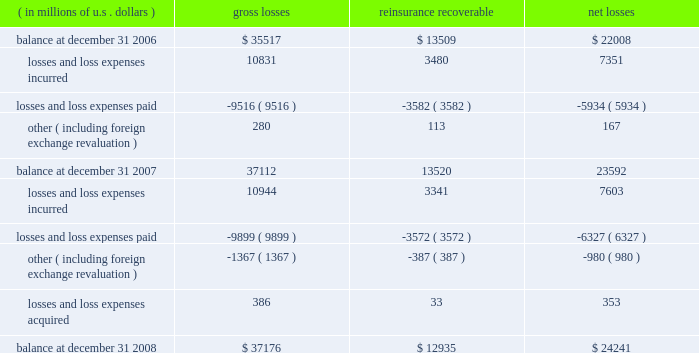We are continuing to invest in people and infrastructure to grow our presence in lines of businesses globally where we see an opportunity for ace to grow market share at reasonable terms .
We are also continuing to invest in our enterprise risk management capability , our systems and data environment , and our research and development capabilities .
Critical accounting estimates our consolidated financial statements include amounts that , either by their nature or due to requirements of accounting princi- ples generally accepted in the u.s .
( gaap ) , are determined using best estimates and assumptions .
While we believe that the amounts included in our consolidated financial statements reflect our best judgment , actual amounts could ultimately materi- ally differ from those currently presented .
We believe the items that require the most subjective and complex estimates are : 2022 unpaid loss and loss expense reserves , including long-tail asbestos and environmental ( a&e ) reserves ; 2022 future policy benefits reserves ; 2022 valuation of value of business acquired ( voba ) and amortization of deferred policy acquisition costs and voba ; 2022 the assessment of risk transfer for certain structured insurance and reinsurance contracts ; 2022 reinsurance recoverable , including a provision for uncollectible reinsurance ; 2022 impairments to the carrying value of our investment portfolio ; 2022 the valuation of deferred tax assets ; 2022 the valuation of derivative instruments related to guaranteed minimum income benefits ( gmib ) ; and 2022 the valuation of goodwill .
We believe our accounting policies for these items are of critical importance to our consolidated financial statements .
The following discussion provides more information regarding the estimates and assumptions required to arrive at these amounts and should be read in conjunction with the sections entitled : prior period development , asbestos and environmental and other run-off liabilities , reinsurance recoverable on ceded reinsurance , investments , net realized gains ( losses ) , and other income and expense items .
Unpaid losses and loss expenses as an insurance and reinsurance company , we are required , by applicable laws and regulations and gaap , to establish loss and loss expense reserves for the estimated unpaid portion of the ultimate liability for losses and loss expenses under the terms of our policies and agreements with our insured and reinsured customers .
The estimate of the liabilities includes provisions for claims that have been reported but unpaid at the balance sheet date ( case reserves ) and for future obligations from claims that have been incurred but not reported ( ibnr ) at the balance sheet date ( ibnr may also include a provision for additional devel- opment on reported claims in instances where the case reserve is viewed to be potentially insufficient ) .
The reserves provide for liabilities that exist for the company as of the balance sheet date .
The loss reserve also includes an estimate of expenses associated with processing and settling these unpaid claims ( loss expenses ) .
At december 31 , 2008 , our gross unpaid loss and loss expense reserves were $ 37.2 billion and our net unpaid loss and loss expense reserves were $ 24.2 billion .
With the exception of certain structured settlements , for which the timing and amount of future claim payments are reliably determi- nable , our loss reserves are not discounted for the time value of money .
In connection with such structured settlements , we carry reserves of $ 106 million ( net of discount ) .
The table below presents a roll-forward of our unpaid losses and loss expenses for the indicated periods .
( in millions of u.s .
Dollars ) losses reinsurance recoverable net losses .

What are is the net change in the balance of unpaid losses during 2007? 
Computations: ((7351 + -5934) + 167)
Answer: 1584.0. 